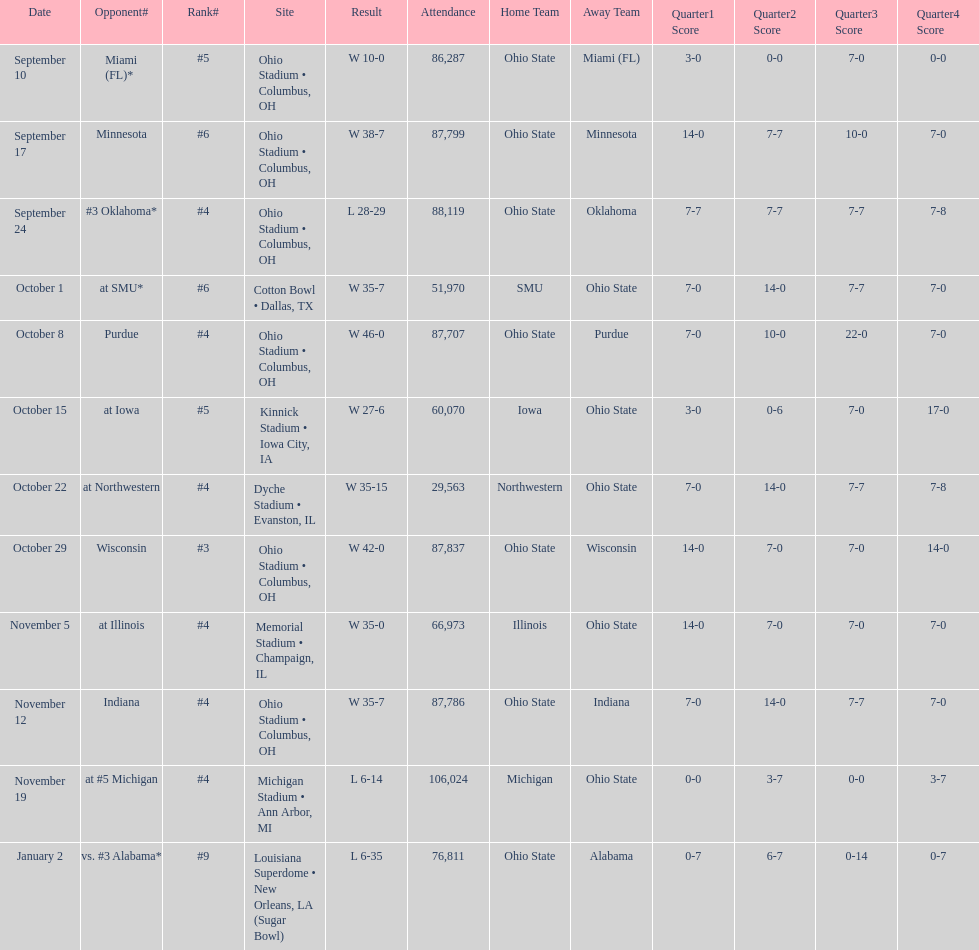Which was the most recent game with an attendance of less than 30,000 individuals? October 22. 